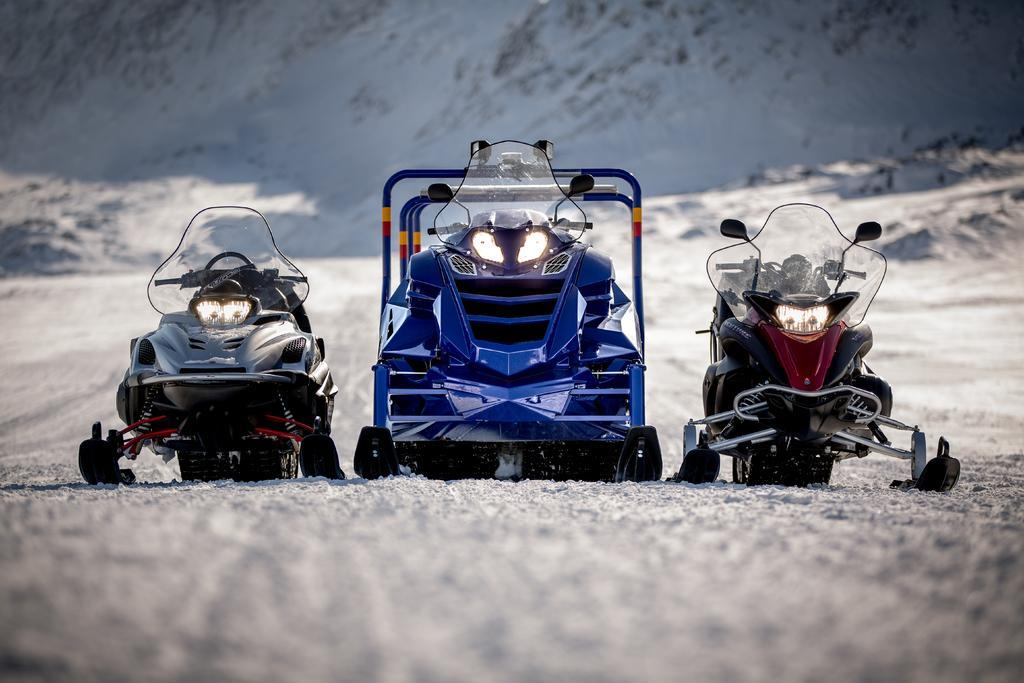What types of vehicles are in the image? The image contains vehicles, but the specific types are not mentioned. What natural feature can be seen in the image? There is a mountain visible in the image. What is the condition of the mountain? The mountain has snow on it. What type of stew is being served at the mountain in the image? There is no mention of stew or any food being served in the image. What idea does the mountain represent in the image? The image does not convey any specific ideas or concepts related to the mountain. 